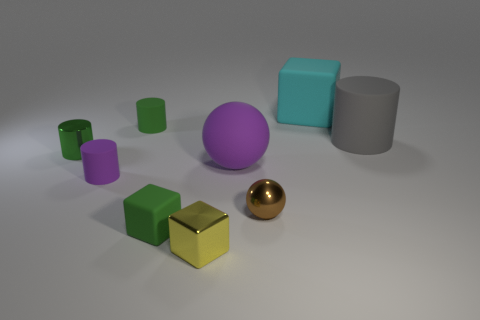What is the shape of the cyan matte object?
Your response must be concise. Cube. Are there more large gray matte cylinders in front of the small brown object than brown spheres that are to the left of the tiny yellow object?
Provide a succinct answer. No. What number of other things are the same size as the matte ball?
Provide a succinct answer. 2. What is the material of the big object that is both right of the purple ball and to the left of the big gray matte cylinder?
Provide a short and direct response. Rubber. There is a yellow thing that is the same shape as the big cyan thing; what material is it?
Ensure brevity in your answer.  Metal. There is a green rubber object in front of the green matte thing that is behind the green metal thing; how many purple matte things are behind it?
Keep it short and to the point. 2. Is there anything else of the same color as the shiny sphere?
Your answer should be very brief. No. What number of big things are in front of the large matte block and on the right side of the tiny brown shiny thing?
Provide a succinct answer. 1. There is a cube that is on the right side of the brown ball; is it the same size as the green thing in front of the shiny cylinder?
Offer a terse response. No. What number of things are small matte objects that are in front of the small purple rubber cylinder or big cyan things?
Keep it short and to the point. 2. 